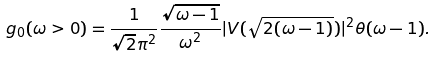Convert formula to latex. <formula><loc_0><loc_0><loc_500><loc_500>g _ { 0 } ( \omega > 0 ) = \frac { 1 } { \sqrt { 2 } \pi ^ { 2 } } \frac { \sqrt { \omega - 1 } } { \omega ^ { 2 } } | V ( \sqrt { 2 ( \omega - 1 ) } ) | ^ { 2 } \theta ( \omega - 1 ) .</formula> 